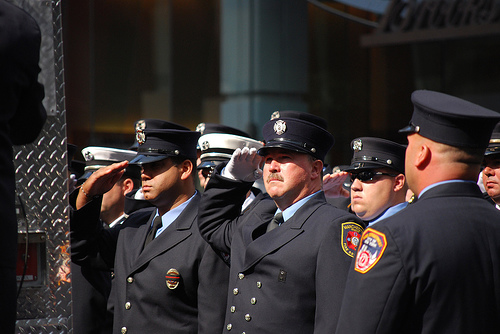<image>
Can you confirm if the hat is above the man face? Yes. The hat is positioned above the man face in the vertical space, higher up in the scene. 